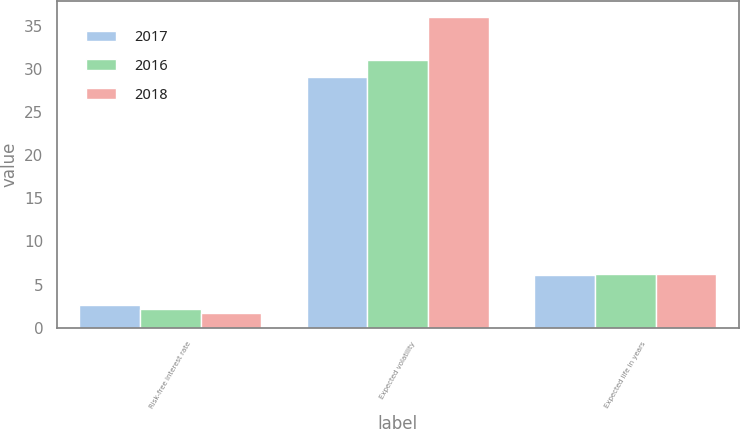<chart> <loc_0><loc_0><loc_500><loc_500><stacked_bar_chart><ecel><fcel>Risk-free interest rate<fcel>Expected volatility<fcel>Expected life in years<nl><fcel>2017<fcel>2.62<fcel>29<fcel>6.15<nl><fcel>2016<fcel>2.13<fcel>31<fcel>6.17<nl><fcel>2018<fcel>1.7<fcel>36<fcel>6.25<nl></chart> 